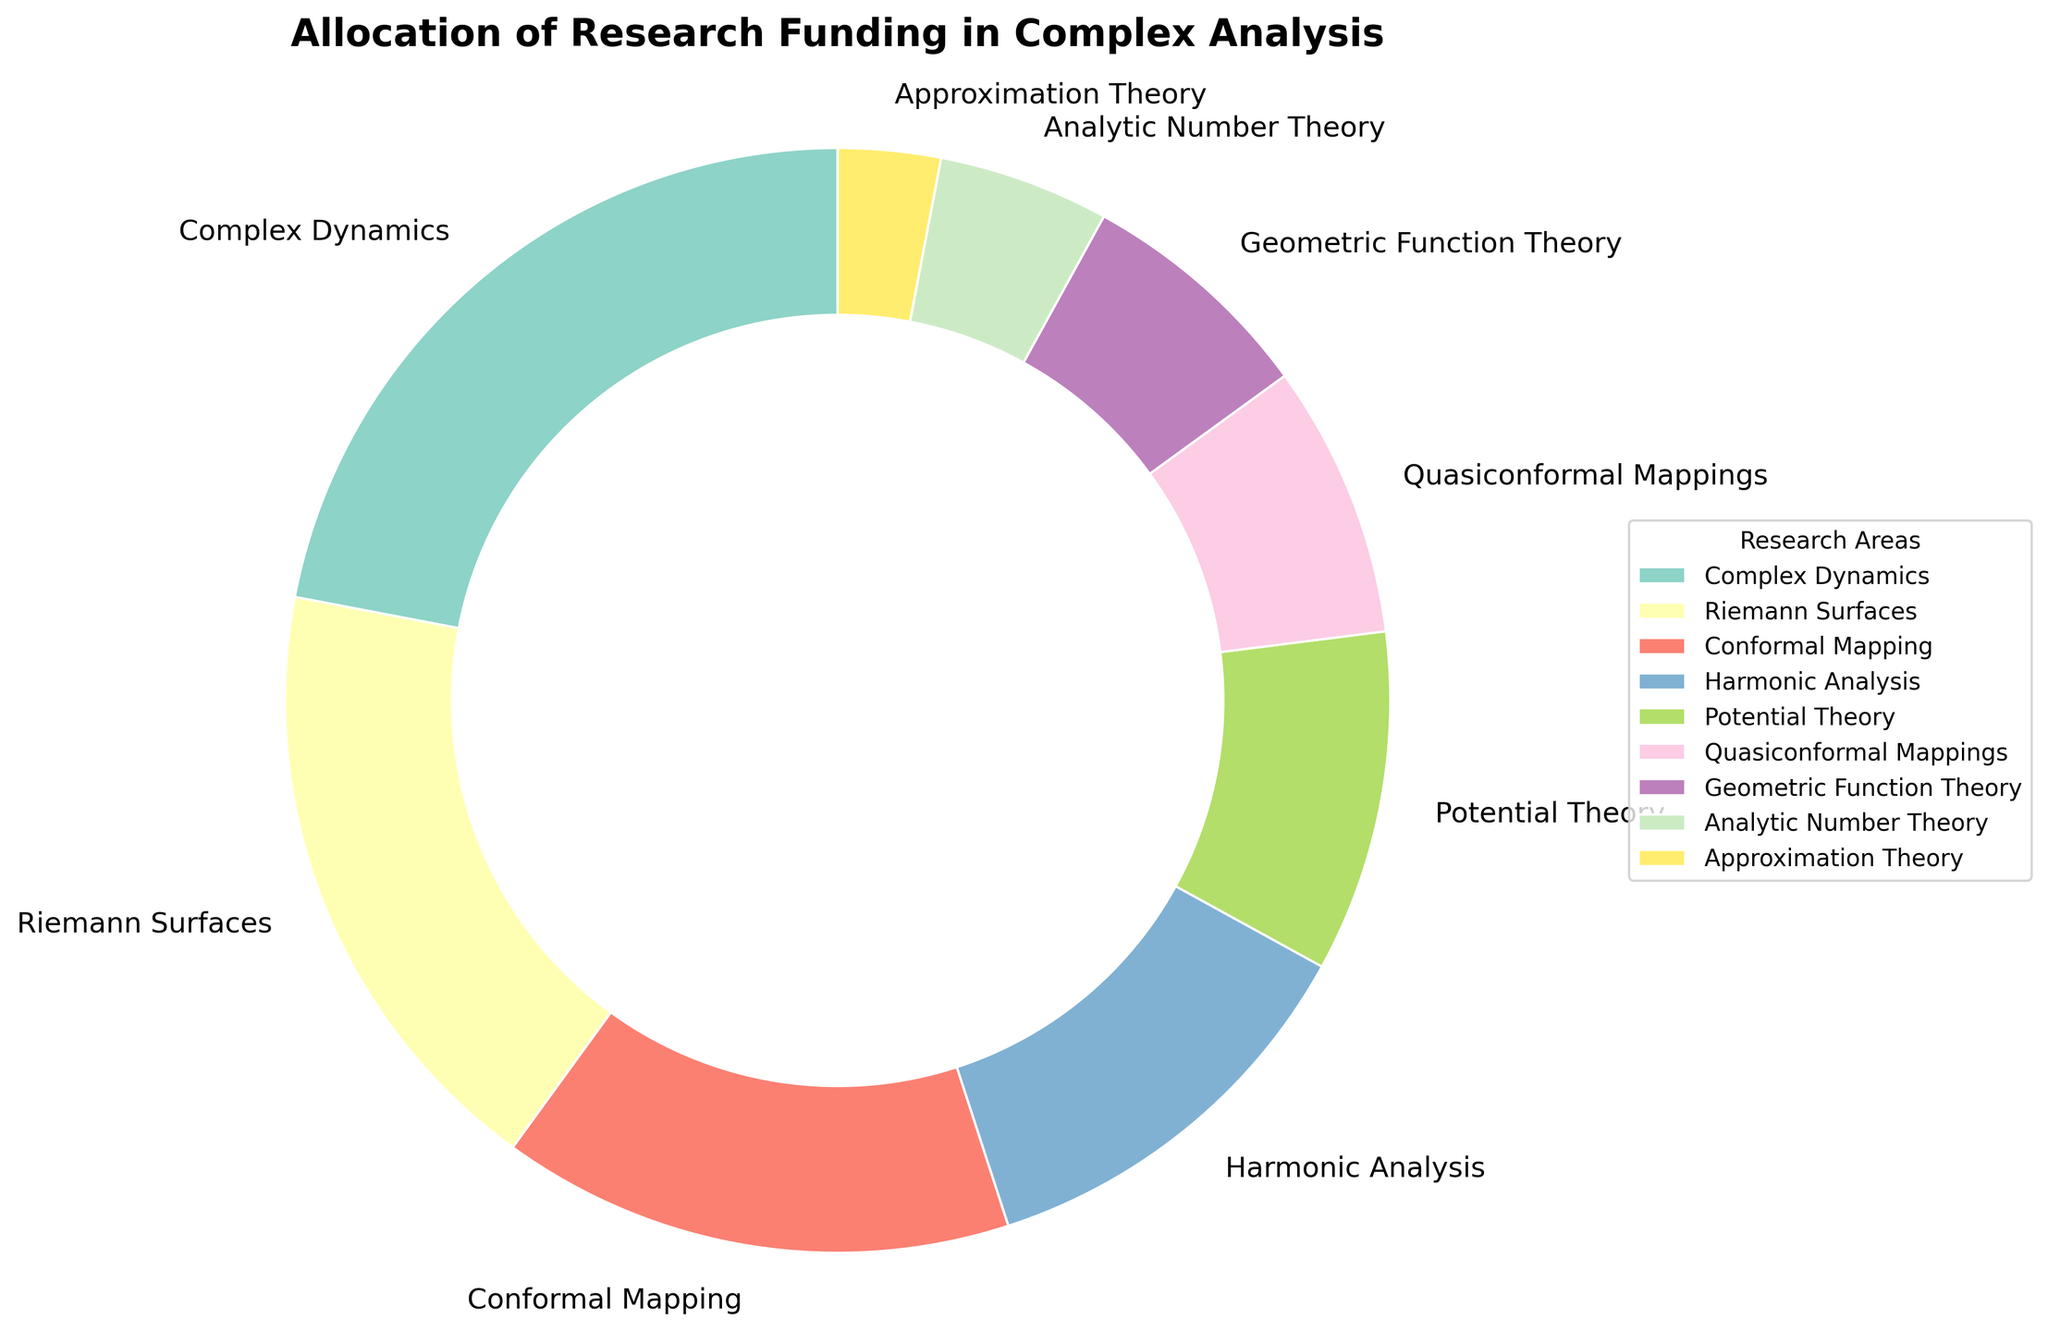What percentage of the total funding is allocated to Complex Dynamics and Riemann Surfaces combined? Complex Dynamics has 22% and Riemann Surfaces have 18%. Adding these percentages gives 22 + 18 = 40%.
Answer: 40% Which research area received the least amount of funding? Analytic Number Theory has the smallest slice of the pie chart, indicating the lowest funding percentage at 3%.
Answer: Analytic Number Theory How much more funding does Complex Dynamics receive compared to Potential Theory? Complex Dynamics gets 22% of the funding, while Potential Theory gets 10%. Hence, Complex Dynamics receives 22 - 10 = 12% more funding than Potential Theory.
Answer: 12% What is the difference in funding allocation between Harmonic Analysis and Geometric Function Theory? Harmonic Analysis has 12% and Geometric Function Theory has 7%. The difference is 12 - 7 = 5%.
Answer: 5% Which two areas together receive as much or slightly more funding than Complex Dynamics alone? Complex Dynamics receives 22%. Riemann Surfaces get 18% and Approximations Theory gets 3%. Adding these areas together, 18 + 3 = 21%, does not match but Harmonic Analysis (12%) and Potential Theory (10%) together give 12 + 10 = 22% matching the funding for Complex Dynamics
Answer: Harmonic Analysis and Potential Theory Is the funding for Quasiconformal Mappings more than half of the funding for Complex Dynamics? Quasiconformal Mappings receive 8% of the funding, while Complex Dynamics gets 22%. Evaluating 22 / 2 = 11%, and 8 < 11, so Quasiconformal Mappings receive less than half of the funding for Complex Dynamics.
Answer: No Which research area receives a funding percentage closest to that of Potential Theory? Potential Theory receives 10% of the funding. The closest funding percentage to this is that of Quasiconformal Mappings at 8%.
Answer: Quasiconformal Mappings How many research areas receive equal or less funding than Conformal Mapping? Conformal Mapping receives 15% of the funding. The areas receiving equal or less funding than Conformal Mapping include Harmonic Analysis (12%), Potential Theory (10%), Quasiconformal Mappings (8%), Geometric Function Theory (7%), Analytic Number Theory (5%), and Approximation Theory (3%). There are 6 such areas.
Answer: 6 